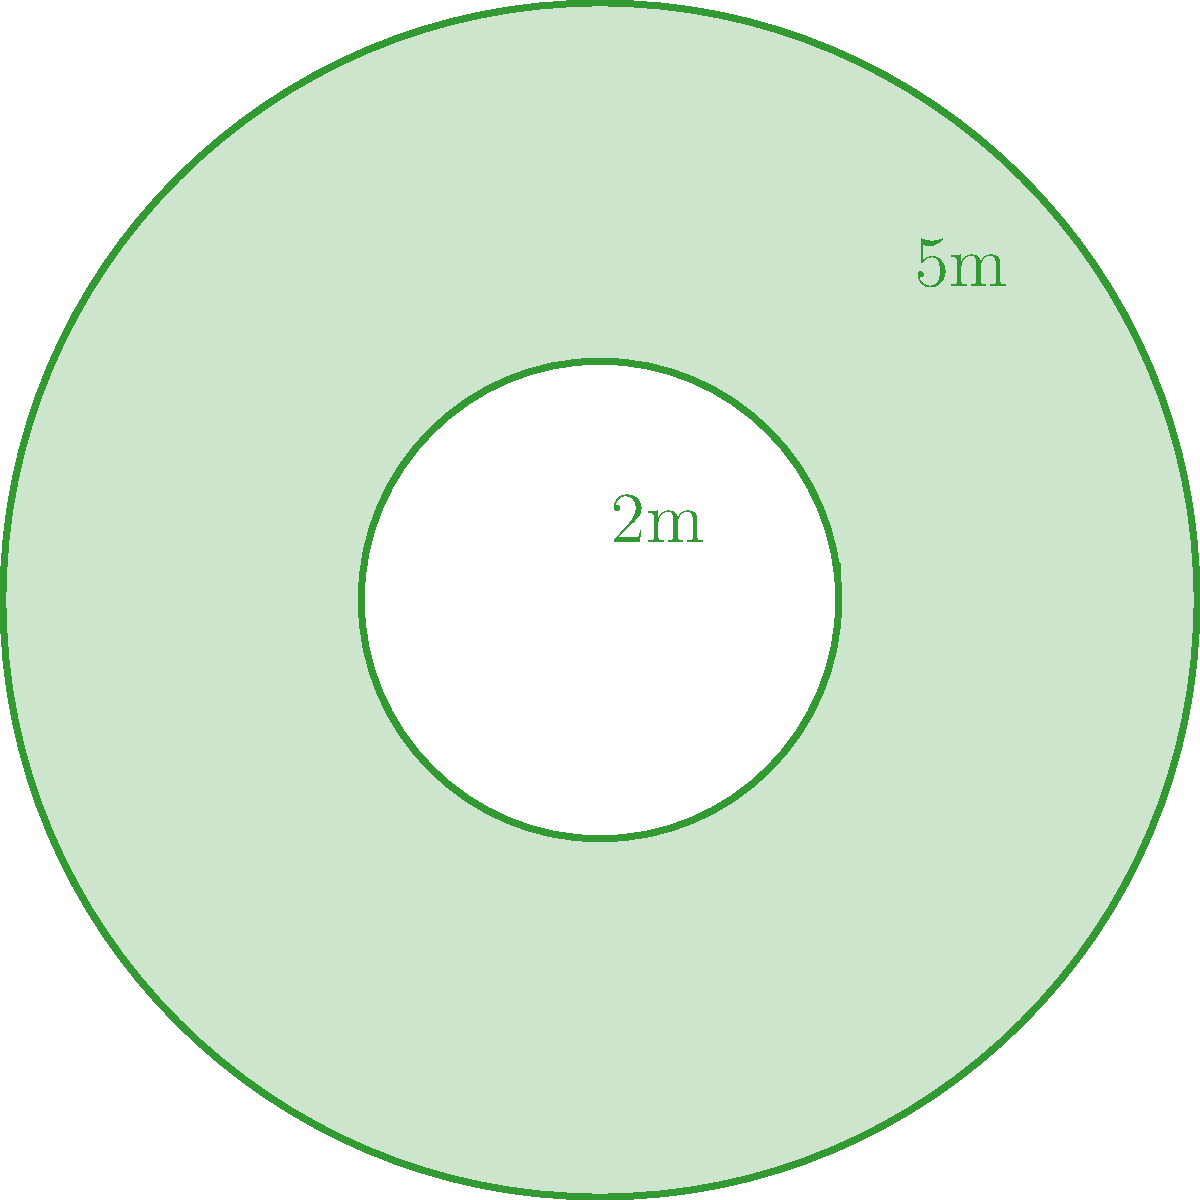As part of an eco-friendly film festival, you're designing a unique garden plot shaped like a film reel to showcase sustainable landscaping. The outer radius of the garden is 5 meters, and the inner radius (representing the reel's center) is 2 meters. Calculate the area of the garden plot that can be planted. Round your answer to the nearest square meter. To find the area of the film reel-shaped garden plot, we need to:

1. Calculate the area of the larger circle (outer radius)
2. Calculate the area of the smaller circle (inner radius)
3. Subtract the smaller area from the larger area

Step 1: Area of the larger circle
$$A_1 = \pi r_1^2 = \pi (5\text{m})^2 = 25\pi \text{ m}^2$$

Step 2: Area of the smaller circle
$$A_2 = \pi r_2^2 = \pi (2\text{m})^2 = 4\pi \text{ m}^2$$

Step 3: Area of the garden plot
$$A_{\text{garden}} = A_1 - A_2 = 25\pi \text{ m}^2 - 4\pi \text{ m}^2 = 21\pi \text{ m}^2$$

Step 4: Convert to a numeric value and round to the nearest square meter
$$21\pi \approx 65.97 \text{ m}^2 \approx 66 \text{ m}^2$$

Therefore, the area of the garden plot that can be planted is approximately 66 square meters.
Answer: 66 m² 